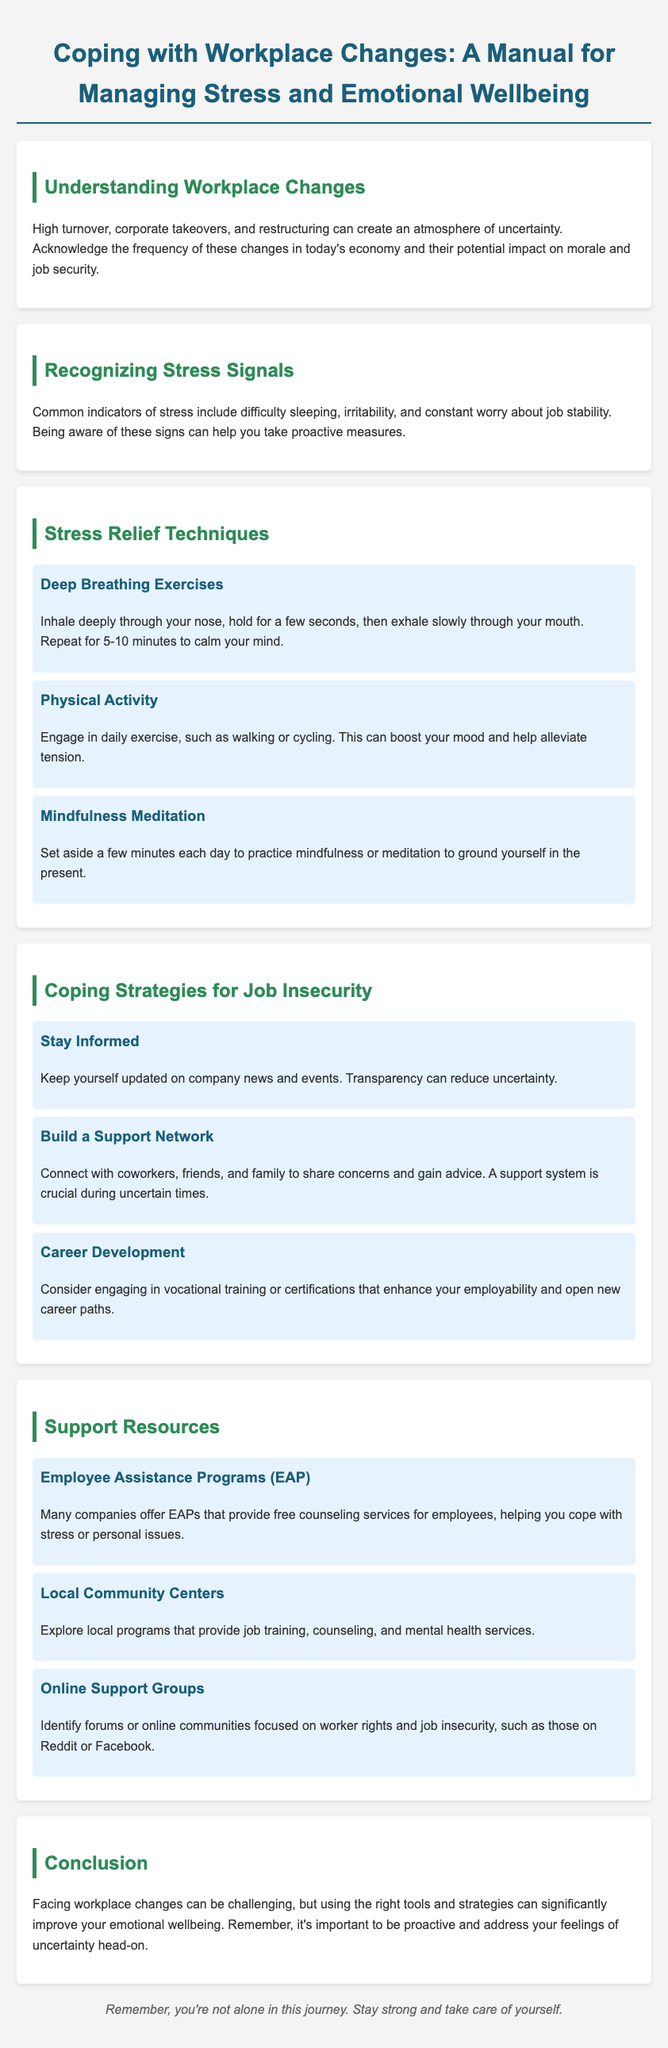What are two common indicators of stress? The document lists common indicators of stress, which include difficulty sleeping and irritability.
Answer: difficulty sleeping, irritability What is one technique for stress relief mentioned in the manual? The manual provides several techniques for stress relief, one of which is Deep Breathing Exercises.
Answer: Deep Breathing Exercises How can staying informed help during workplace changes? It explains that keeping yourself updated can reduce uncertainty, which supports well-being.
Answer: reduce uncertainty What should you do to build a support network? The document suggests connecting with coworkers, friends, and family to share concerns and gain advice.
Answer: connect with coworkers, friends, and family What type of counseling services do Employee Assistance Programs provide? The manual states that EAPs provide free counseling services for employees to help cope with stress or personal issues.
Answer: free counseling services What is one resource for job training mentioned in the manual? Among the resources listed, Local Community Centers are mentioned as offering job training.
Answer: Local Community Centers What is a focus of online support groups mentioned in the document? The document indicates that online support groups focus on worker rights and job insecurity.
Answer: worker rights and job insecurity What is the overall message in the conclusion? The conclusion emphasizes the importance of being proactive in addressing feelings of uncertainty.
Answer: be proactive 